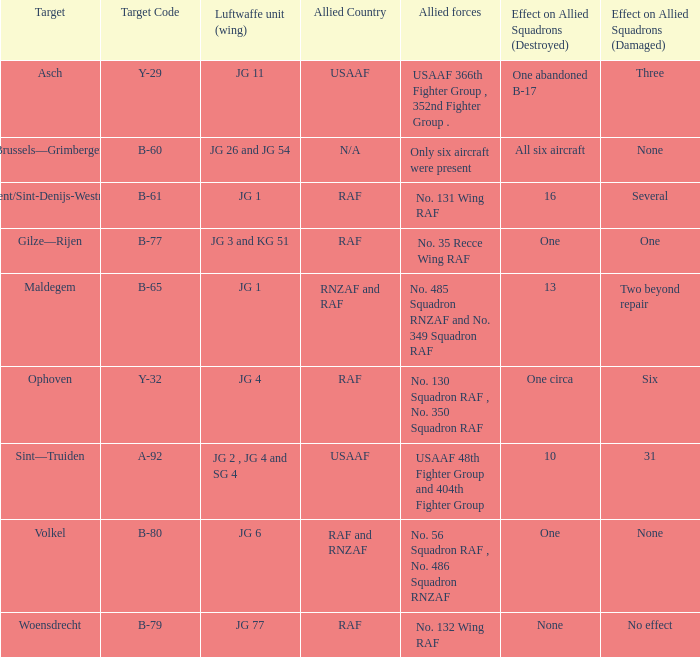Which Allied Force targetted Woensdrecht? No. 132 Wing RAF. 